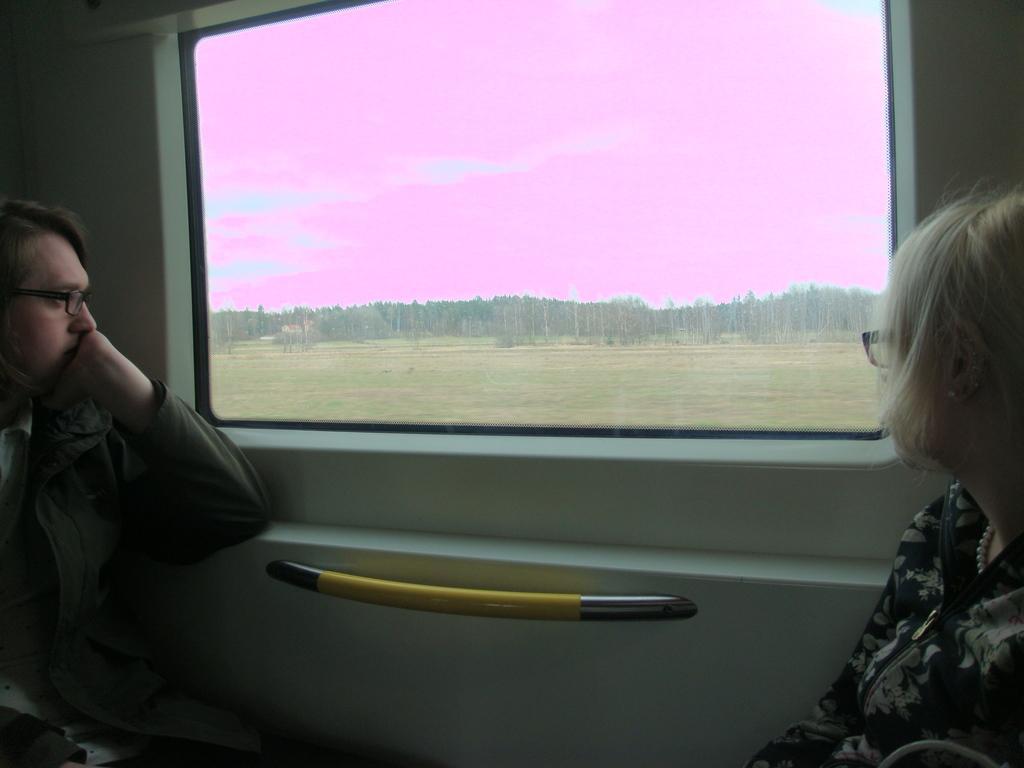Please provide a concise description of this image. In the image we can see there are two people wearing clothes and spectacles, they are sitting near the window. There is a window and out of the window we can see grass, tree and a sky. This is a neck chain. 